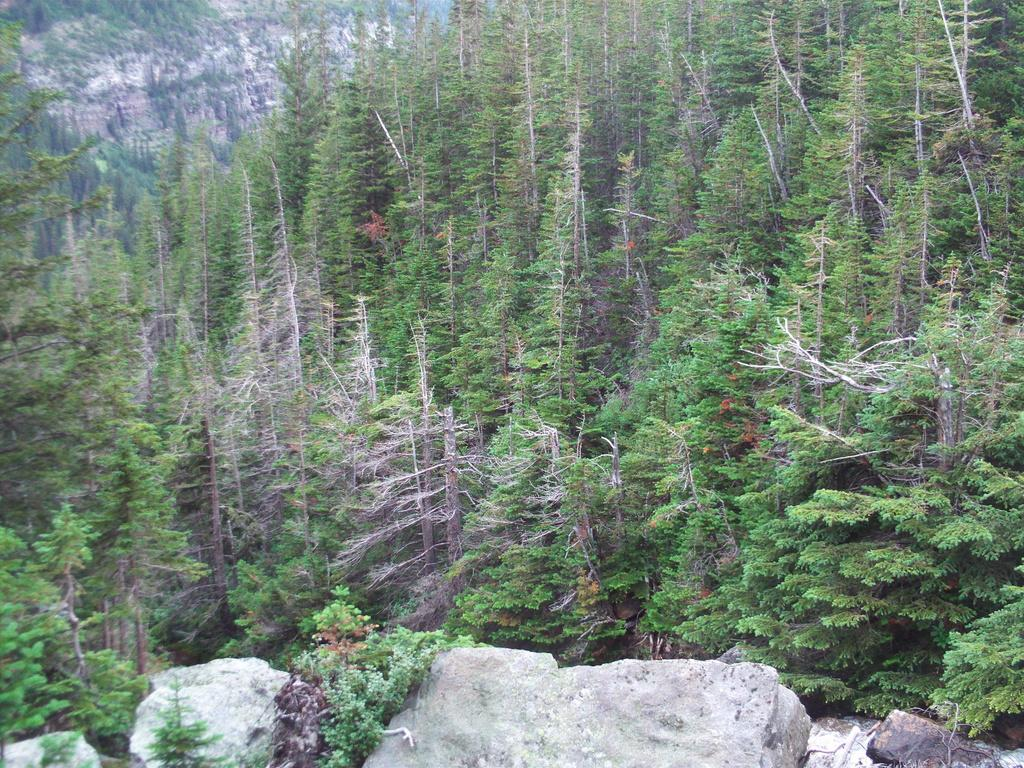What type of landscape is depicted in the image? The image features hills, trees, water, and rocks. Can you describe the natural elements present in the image? There are hills, trees, water, and rocks visible in the image. What type of water can be seen in the image? The water visible in the image is not specified, but it could be a river, lake, or ocean. Where is the doctor's desk located in the image? There is no doctor or desk present in the image; it features a natural landscape with hills, trees, water, and rocks. 